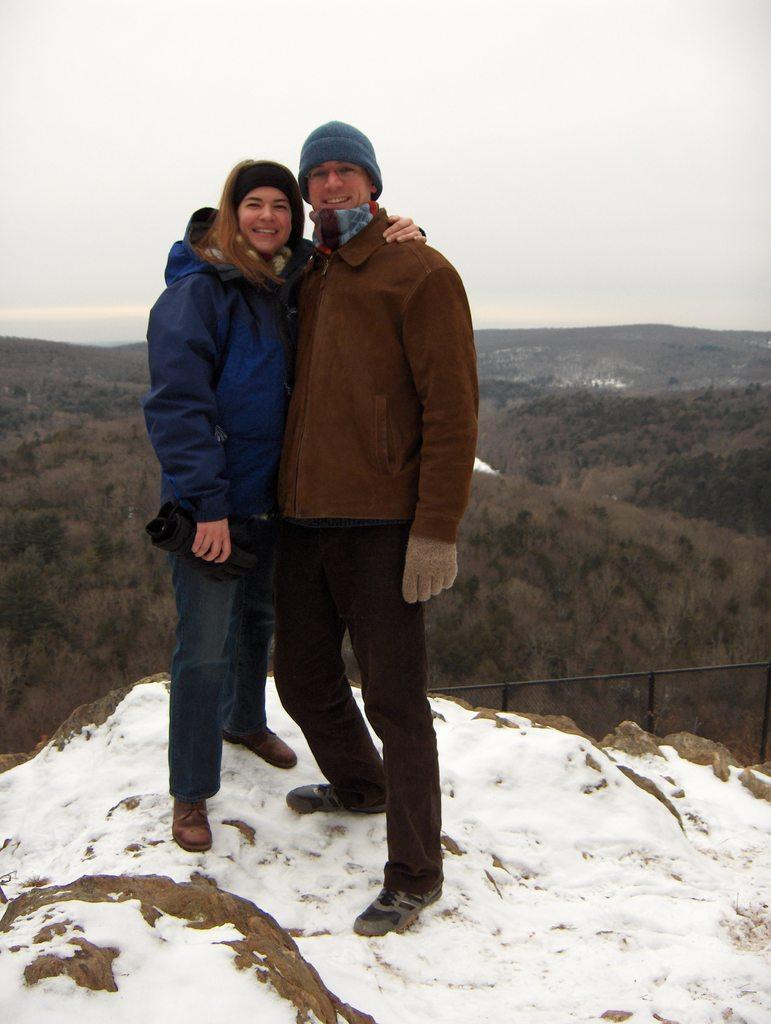How many people are in the image? There are two people in the image. What is the facial expression of the people in the image? The people are smiling. What type of clothing are the people wearing? The people are wearing jackets. What is the weather condition in the image? There is snow on the surface in the image, indicating a cold and snowy environment. What type of cork can be seen popping out of the snow in the image? There is no cork present in the image; it features two people wearing jackets and smiling in a snowy environment. 